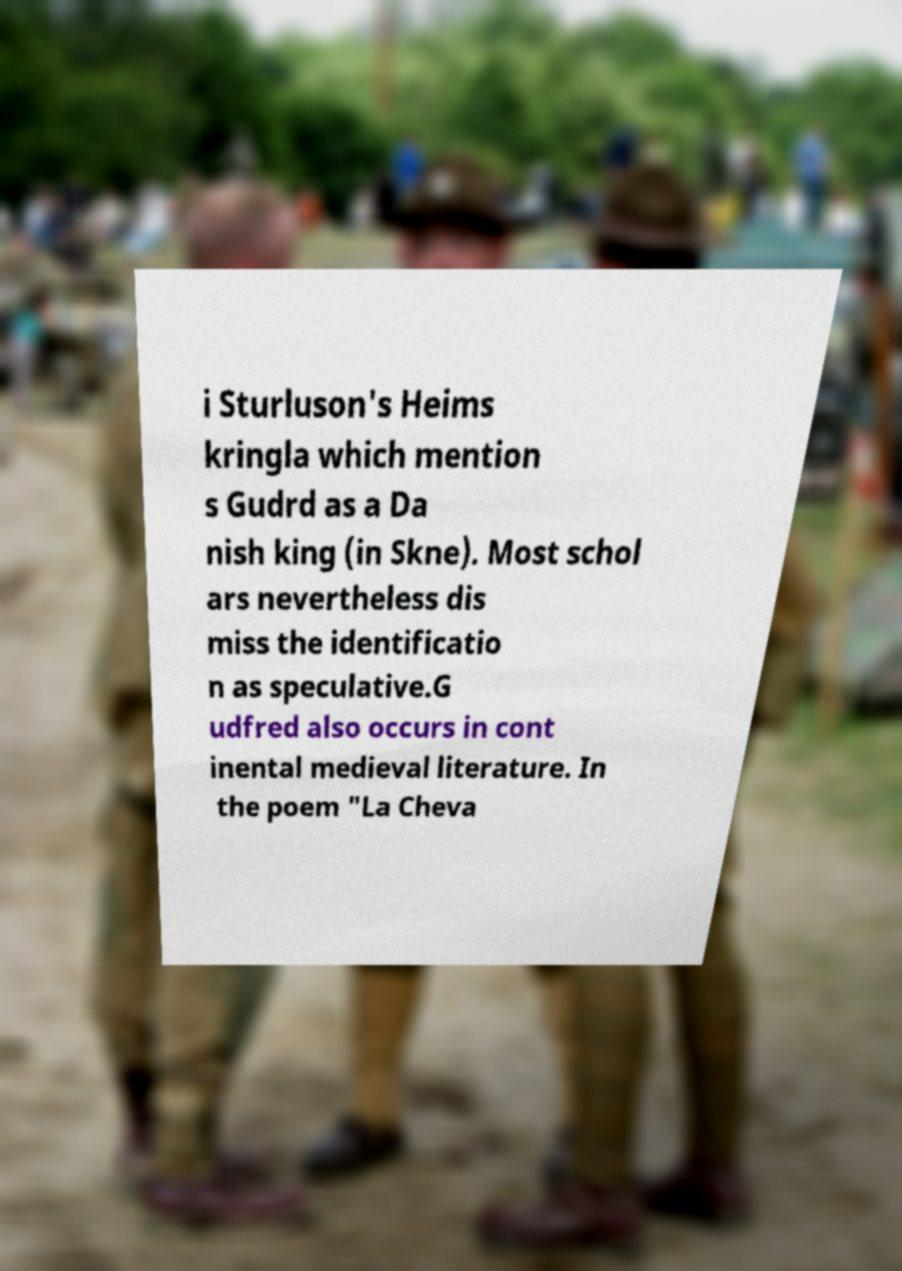There's text embedded in this image that I need extracted. Can you transcribe it verbatim? i Sturluson's Heims kringla which mention s Gudrd as a Da nish king (in Skne). Most schol ars nevertheless dis miss the identificatio n as speculative.G udfred also occurs in cont inental medieval literature. In the poem "La Cheva 